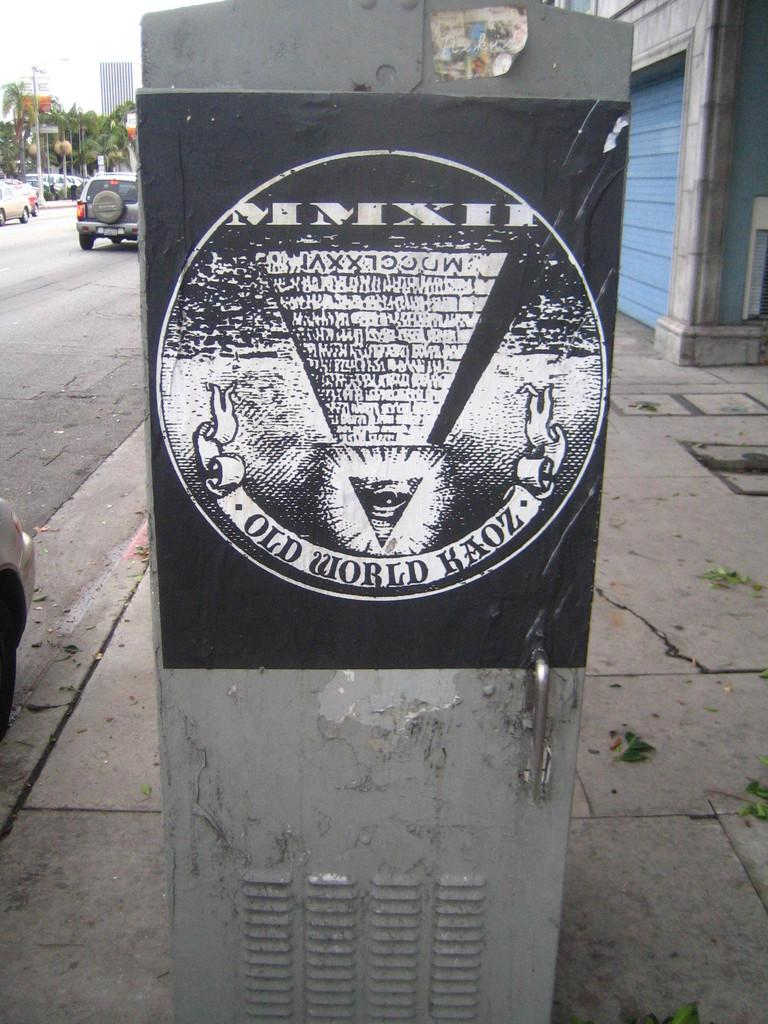Provide a one-sentence caption for the provided image. A poster sits on a untility unit which says Old World Haoz. 